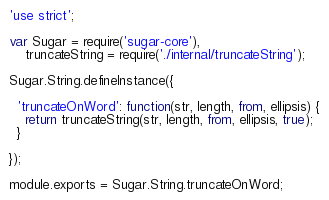Convert code to text. <code><loc_0><loc_0><loc_500><loc_500><_JavaScript_>'use strict';

var Sugar = require('sugar-core'),
    truncateString = require('./internal/truncateString');

Sugar.String.defineInstance({

  'truncateOnWord': function(str, length, from, ellipsis) {
    return truncateString(str, length, from, ellipsis, true);
  }

});

module.exports = Sugar.String.truncateOnWord;</code> 